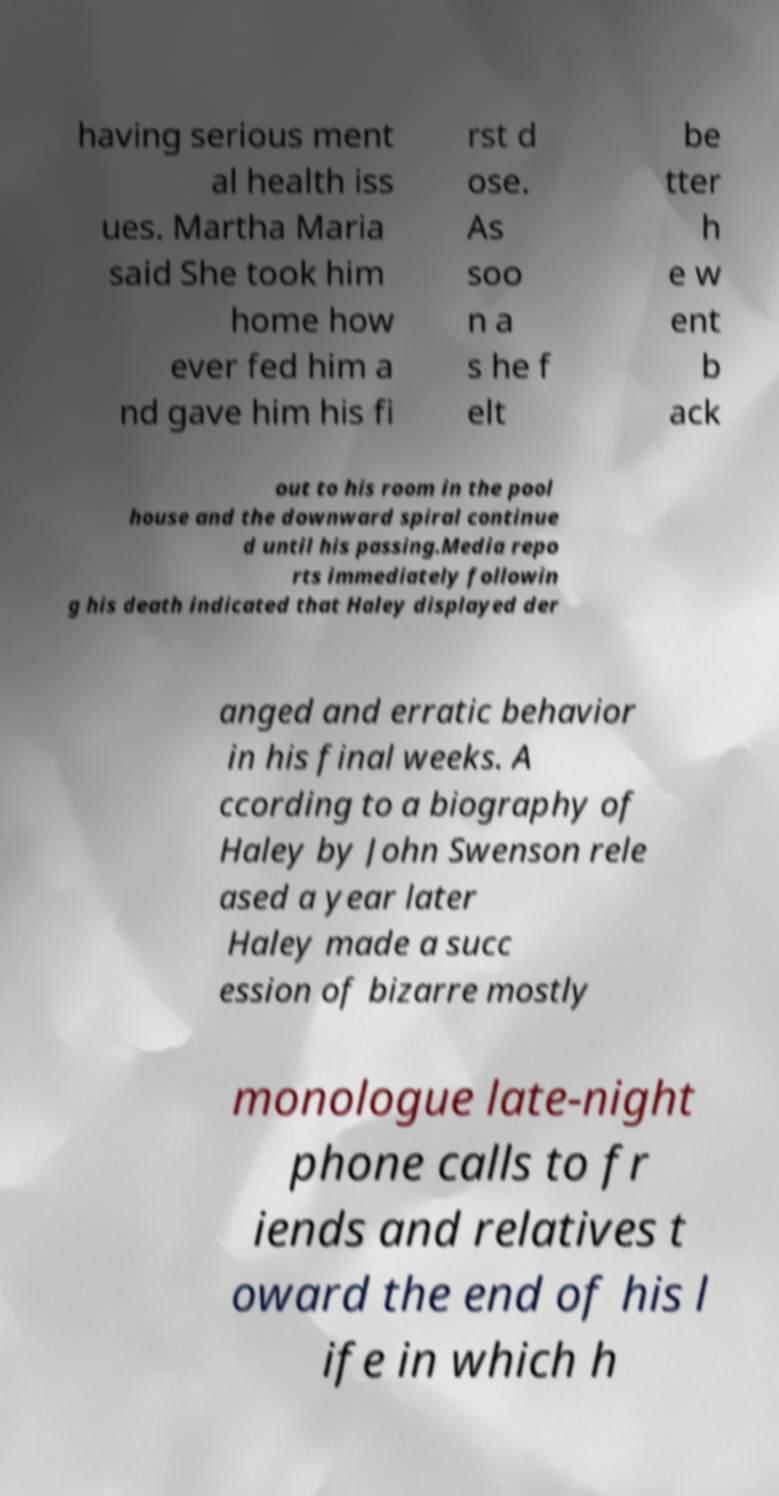Could you extract and type out the text from this image? having serious ment al health iss ues. Martha Maria said She took him home how ever fed him a nd gave him his fi rst d ose. As soo n a s he f elt be tter h e w ent b ack out to his room in the pool house and the downward spiral continue d until his passing.Media repo rts immediately followin g his death indicated that Haley displayed der anged and erratic behavior in his final weeks. A ccording to a biography of Haley by John Swenson rele ased a year later Haley made a succ ession of bizarre mostly monologue late-night phone calls to fr iends and relatives t oward the end of his l ife in which h 